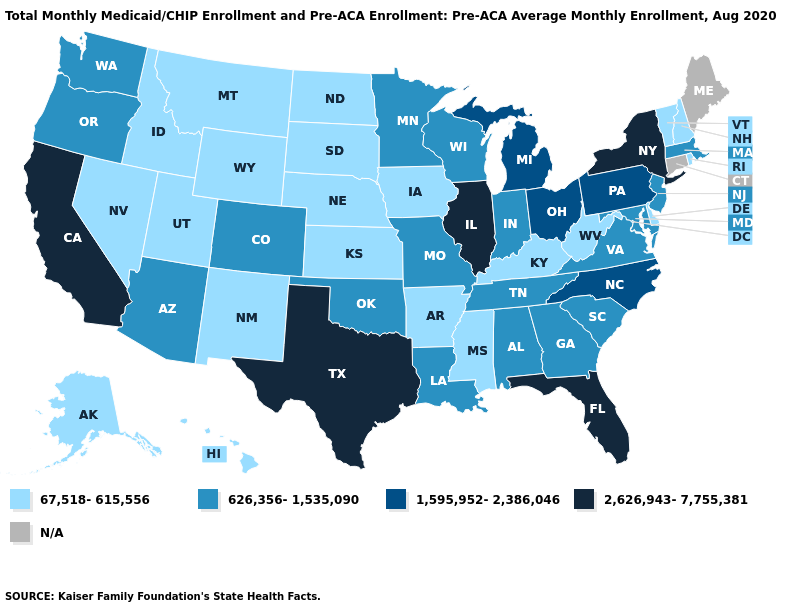Does the map have missing data?
Keep it brief. Yes. Which states have the highest value in the USA?
Give a very brief answer. California, Florida, Illinois, New York, Texas. Among the states that border Tennessee , does Arkansas have the lowest value?
Short answer required. Yes. Name the states that have a value in the range 626,356-1,535,090?
Quick response, please. Alabama, Arizona, Colorado, Georgia, Indiana, Louisiana, Maryland, Massachusetts, Minnesota, Missouri, New Jersey, Oklahoma, Oregon, South Carolina, Tennessee, Virginia, Washington, Wisconsin. Name the states that have a value in the range 626,356-1,535,090?
Keep it brief. Alabama, Arizona, Colorado, Georgia, Indiana, Louisiana, Maryland, Massachusetts, Minnesota, Missouri, New Jersey, Oklahoma, Oregon, South Carolina, Tennessee, Virginia, Washington, Wisconsin. Which states have the lowest value in the USA?
Give a very brief answer. Alaska, Arkansas, Delaware, Hawaii, Idaho, Iowa, Kansas, Kentucky, Mississippi, Montana, Nebraska, Nevada, New Hampshire, New Mexico, North Dakota, Rhode Island, South Dakota, Utah, Vermont, West Virginia, Wyoming. Name the states that have a value in the range N/A?
Answer briefly. Connecticut, Maine. Name the states that have a value in the range 1,595,952-2,386,046?
Short answer required. Michigan, North Carolina, Ohio, Pennsylvania. Does the first symbol in the legend represent the smallest category?
Concise answer only. Yes. Name the states that have a value in the range 626,356-1,535,090?
Give a very brief answer. Alabama, Arizona, Colorado, Georgia, Indiana, Louisiana, Maryland, Massachusetts, Minnesota, Missouri, New Jersey, Oklahoma, Oregon, South Carolina, Tennessee, Virginia, Washington, Wisconsin. Among the states that border Pennsylvania , does Delaware have the lowest value?
Give a very brief answer. Yes. Name the states that have a value in the range 67,518-615,556?
Quick response, please. Alaska, Arkansas, Delaware, Hawaii, Idaho, Iowa, Kansas, Kentucky, Mississippi, Montana, Nebraska, Nevada, New Hampshire, New Mexico, North Dakota, Rhode Island, South Dakota, Utah, Vermont, West Virginia, Wyoming. Is the legend a continuous bar?
Give a very brief answer. No. 